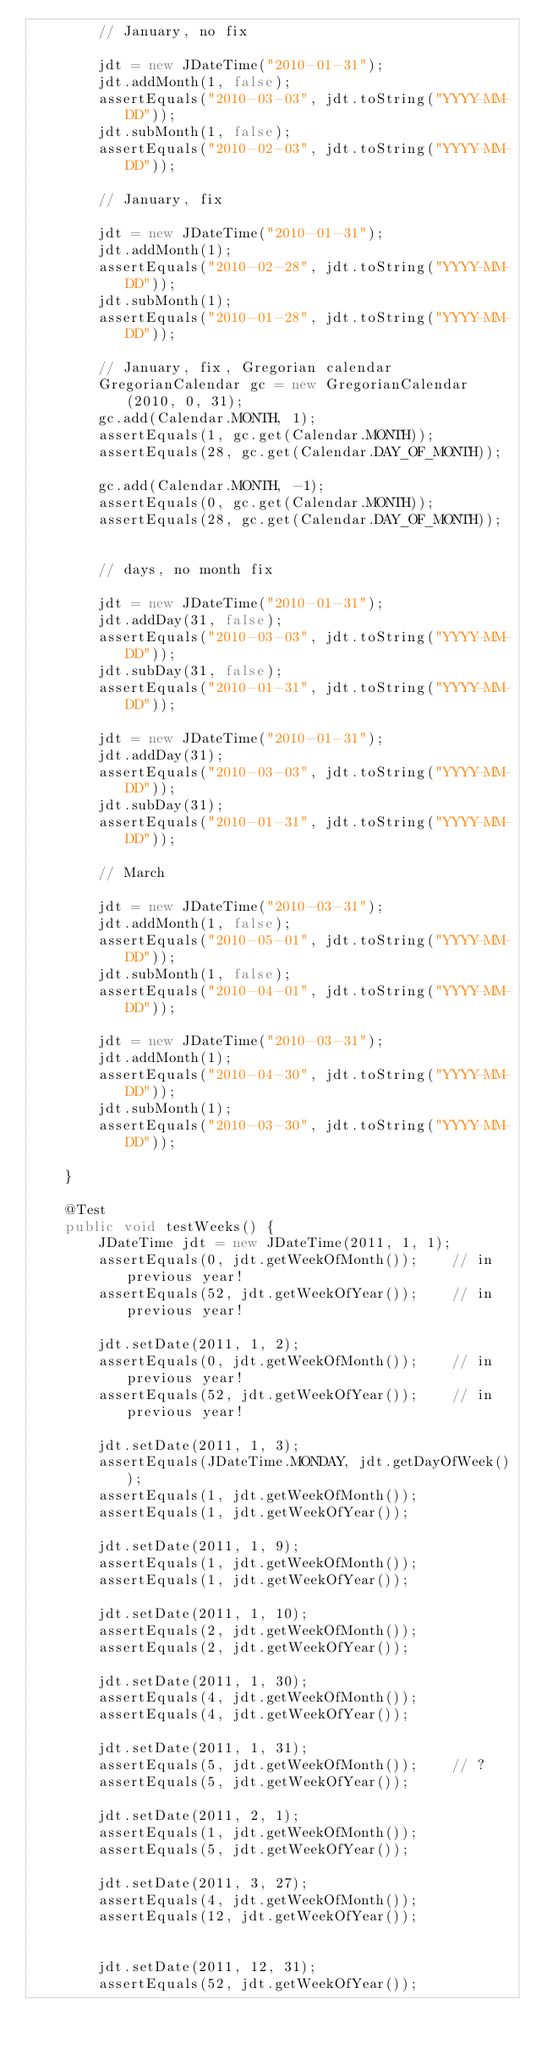Convert code to text. <code><loc_0><loc_0><loc_500><loc_500><_Java_>		// January, no fix

		jdt = new JDateTime("2010-01-31");
		jdt.addMonth(1, false);
		assertEquals("2010-03-03", jdt.toString("YYYY-MM-DD"));
		jdt.subMonth(1, false);
		assertEquals("2010-02-03", jdt.toString("YYYY-MM-DD"));

		// January, fix

		jdt = new JDateTime("2010-01-31");
		jdt.addMonth(1);
		assertEquals("2010-02-28", jdt.toString("YYYY-MM-DD"));
		jdt.subMonth(1);
		assertEquals("2010-01-28", jdt.toString("YYYY-MM-DD"));

		// January, fix, Gregorian calendar
		GregorianCalendar gc = new GregorianCalendar(2010, 0, 31);
		gc.add(Calendar.MONTH, 1);
		assertEquals(1, gc.get(Calendar.MONTH));
		assertEquals(28, gc.get(Calendar.DAY_OF_MONTH));

		gc.add(Calendar.MONTH, -1);
		assertEquals(0, gc.get(Calendar.MONTH));
		assertEquals(28, gc.get(Calendar.DAY_OF_MONTH));


		// days, no month fix

		jdt = new JDateTime("2010-01-31");
		jdt.addDay(31, false);
		assertEquals("2010-03-03", jdt.toString("YYYY-MM-DD"));
		jdt.subDay(31, false);
		assertEquals("2010-01-31", jdt.toString("YYYY-MM-DD"));

		jdt = new JDateTime("2010-01-31");
		jdt.addDay(31);
		assertEquals("2010-03-03", jdt.toString("YYYY-MM-DD"));
		jdt.subDay(31);
		assertEquals("2010-01-31", jdt.toString("YYYY-MM-DD"));

		// March

		jdt = new JDateTime("2010-03-31");
		jdt.addMonth(1, false);
		assertEquals("2010-05-01", jdt.toString("YYYY-MM-DD"));
		jdt.subMonth(1, false);
		assertEquals("2010-04-01", jdt.toString("YYYY-MM-DD"));

		jdt = new JDateTime("2010-03-31");
		jdt.addMonth(1);
		assertEquals("2010-04-30", jdt.toString("YYYY-MM-DD"));
		jdt.subMonth(1);
		assertEquals("2010-03-30", jdt.toString("YYYY-MM-DD"));

	}

	@Test
	public void testWeeks() {
		JDateTime jdt = new JDateTime(2011, 1, 1);
		assertEquals(0, jdt.getWeekOfMonth());    // in previous year!
		assertEquals(52, jdt.getWeekOfYear());    // in previous year!

		jdt.setDate(2011, 1, 2);
		assertEquals(0, jdt.getWeekOfMonth());    // in previous year!
		assertEquals(52, jdt.getWeekOfYear());    // in previous year!

		jdt.setDate(2011, 1, 3);
		assertEquals(JDateTime.MONDAY, jdt.getDayOfWeek());
		assertEquals(1, jdt.getWeekOfMonth());
		assertEquals(1, jdt.getWeekOfYear());

		jdt.setDate(2011, 1, 9);
		assertEquals(1, jdt.getWeekOfMonth());
		assertEquals(1, jdt.getWeekOfYear());

		jdt.setDate(2011, 1, 10);
		assertEquals(2, jdt.getWeekOfMonth());
		assertEquals(2, jdt.getWeekOfYear());

		jdt.setDate(2011, 1, 30);
		assertEquals(4, jdt.getWeekOfMonth());
		assertEquals(4, jdt.getWeekOfYear());

		jdt.setDate(2011, 1, 31);
		assertEquals(5, jdt.getWeekOfMonth());    // ?
		assertEquals(5, jdt.getWeekOfYear());

		jdt.setDate(2011, 2, 1);
		assertEquals(1, jdt.getWeekOfMonth());
		assertEquals(5, jdt.getWeekOfYear());

		jdt.setDate(2011, 3, 27);
		assertEquals(4, jdt.getWeekOfMonth());
		assertEquals(12, jdt.getWeekOfYear());


		jdt.setDate(2011, 12, 31);
		assertEquals(52, jdt.getWeekOfYear());</code> 